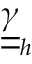Convert formula to latex. <formula><loc_0><loc_0><loc_500><loc_500>\underline { { \underline { \gamma } } } _ { h }</formula> 